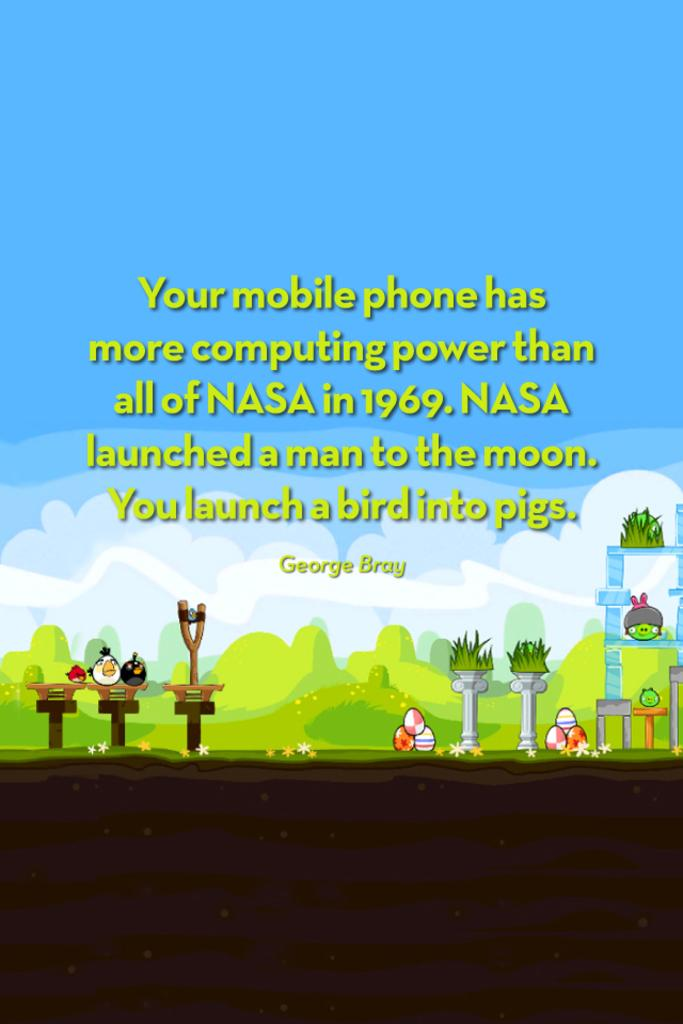<image>
Create a compact narrative representing the image presented. The game Angry Birds is the background for information on mobile phone's computing power compared to NASA in 1969. 